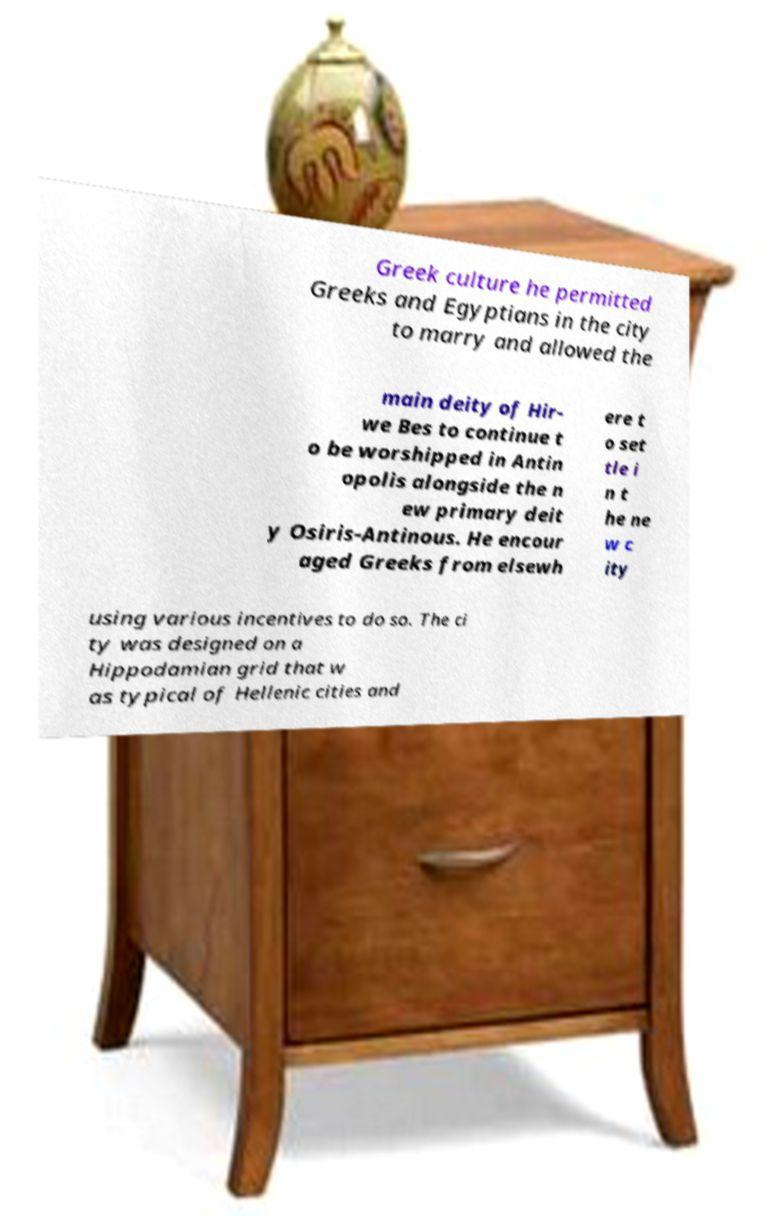For documentation purposes, I need the text within this image transcribed. Could you provide that? Greek culture he permitted Greeks and Egyptians in the city to marry and allowed the main deity of Hir- we Bes to continue t o be worshipped in Antin opolis alongside the n ew primary deit y Osiris-Antinous. He encour aged Greeks from elsewh ere t o set tle i n t he ne w c ity using various incentives to do so. The ci ty was designed on a Hippodamian grid that w as typical of Hellenic cities and 